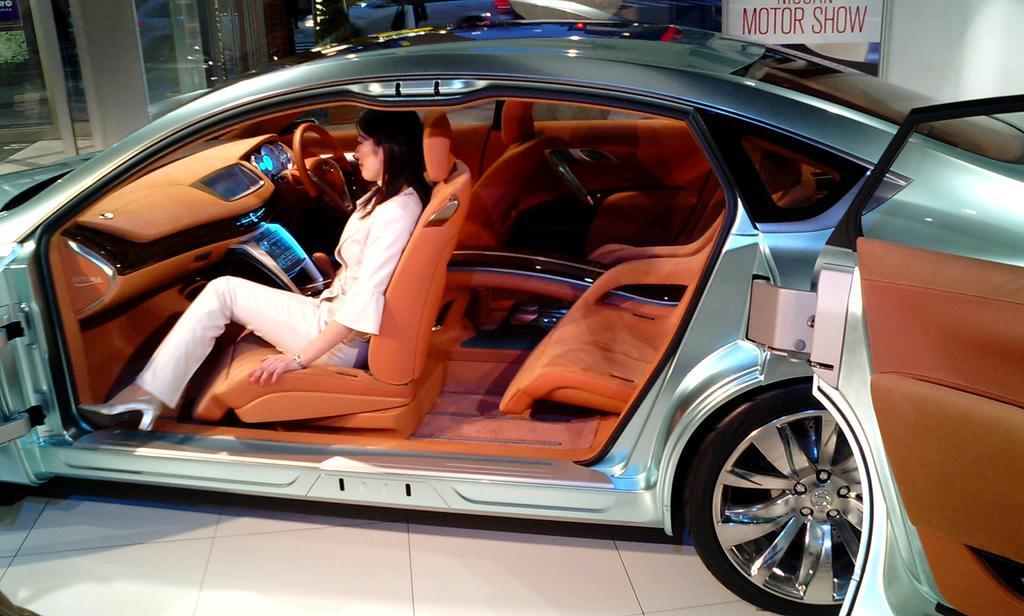Describe this image in one or two sentences. In this picture I can see a car and I can see a woman seated in the car and car doors are opened and I can see a board with some text and It looks like a show room. 